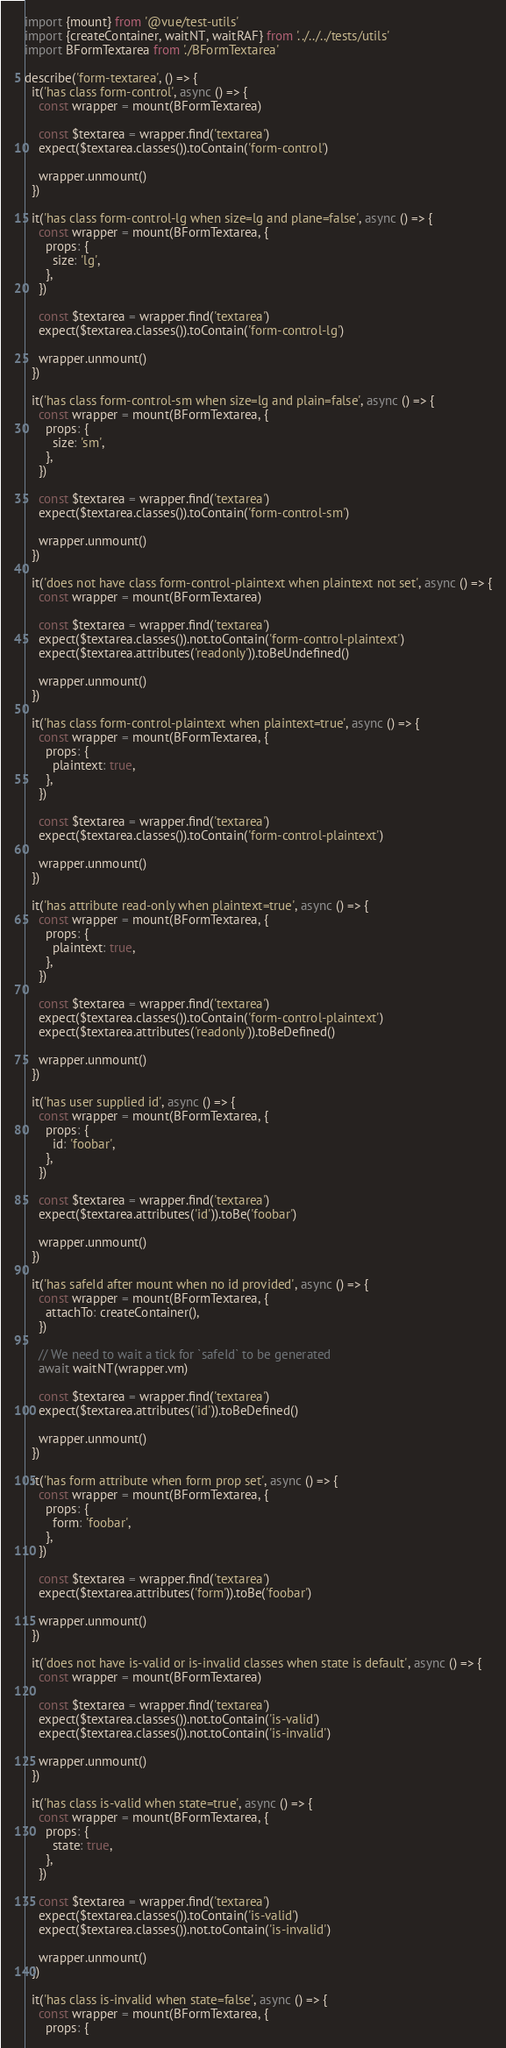Convert code to text. <code><loc_0><loc_0><loc_500><loc_500><_JavaScript_>import {mount} from '@vue/test-utils'
import {createContainer, waitNT, waitRAF} from '../../../tests/utils'
import BFormTextarea from './BFormTextarea'

describe('form-textarea', () => {
  it('has class form-control', async () => {
    const wrapper = mount(BFormTextarea)

    const $textarea = wrapper.find('textarea')
    expect($textarea.classes()).toContain('form-control')

    wrapper.unmount()
  })

  it('has class form-control-lg when size=lg and plane=false', async () => {
    const wrapper = mount(BFormTextarea, {
      props: {
        size: 'lg',
      },
    })

    const $textarea = wrapper.find('textarea')
    expect($textarea.classes()).toContain('form-control-lg')

    wrapper.unmount()
  })

  it('has class form-control-sm when size=lg and plain=false', async () => {
    const wrapper = mount(BFormTextarea, {
      props: {
        size: 'sm',
      },
    })

    const $textarea = wrapper.find('textarea')
    expect($textarea.classes()).toContain('form-control-sm')

    wrapper.unmount()
  })

  it('does not have class form-control-plaintext when plaintext not set', async () => {
    const wrapper = mount(BFormTextarea)

    const $textarea = wrapper.find('textarea')
    expect($textarea.classes()).not.toContain('form-control-plaintext')
    expect($textarea.attributes('readonly')).toBeUndefined()

    wrapper.unmount()
  })

  it('has class form-control-plaintext when plaintext=true', async () => {
    const wrapper = mount(BFormTextarea, {
      props: {
        plaintext: true,
      },
    })

    const $textarea = wrapper.find('textarea')
    expect($textarea.classes()).toContain('form-control-plaintext')

    wrapper.unmount()
  })

  it('has attribute read-only when plaintext=true', async () => {
    const wrapper = mount(BFormTextarea, {
      props: {
        plaintext: true,
      },
    })

    const $textarea = wrapper.find('textarea')
    expect($textarea.classes()).toContain('form-control-plaintext')
    expect($textarea.attributes('readonly')).toBeDefined()

    wrapper.unmount()
  })

  it('has user supplied id', async () => {
    const wrapper = mount(BFormTextarea, {
      props: {
        id: 'foobar',
      },
    })

    const $textarea = wrapper.find('textarea')
    expect($textarea.attributes('id')).toBe('foobar')

    wrapper.unmount()
  })

  it('has safeId after mount when no id provided', async () => {
    const wrapper = mount(BFormTextarea, {
      attachTo: createContainer(),
    })

    // We need to wait a tick for `safeId` to be generated
    await waitNT(wrapper.vm)

    const $textarea = wrapper.find('textarea')
    expect($textarea.attributes('id')).toBeDefined()

    wrapper.unmount()
  })

  it('has form attribute when form prop set', async () => {
    const wrapper = mount(BFormTextarea, {
      props: {
        form: 'foobar',
      },
    })

    const $textarea = wrapper.find('textarea')
    expect($textarea.attributes('form')).toBe('foobar')

    wrapper.unmount()
  })

  it('does not have is-valid or is-invalid classes when state is default', async () => {
    const wrapper = mount(BFormTextarea)

    const $textarea = wrapper.find('textarea')
    expect($textarea.classes()).not.toContain('is-valid')
    expect($textarea.classes()).not.toContain('is-invalid')

    wrapper.unmount()
  })

  it('has class is-valid when state=true', async () => {
    const wrapper = mount(BFormTextarea, {
      props: {
        state: true,
      },
    })

    const $textarea = wrapper.find('textarea')
    expect($textarea.classes()).toContain('is-valid')
    expect($textarea.classes()).not.toContain('is-invalid')

    wrapper.unmount()
  })

  it('has class is-invalid when state=false', async () => {
    const wrapper = mount(BFormTextarea, {
      props: {</code> 